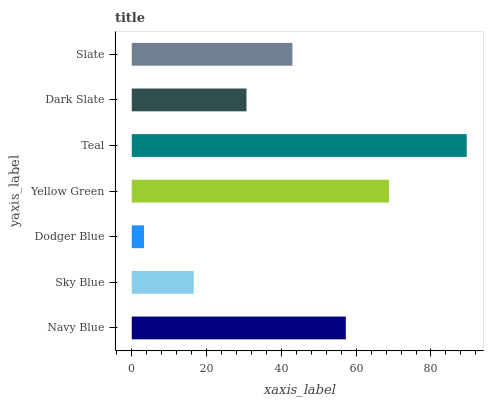Is Dodger Blue the minimum?
Answer yes or no. Yes. Is Teal the maximum?
Answer yes or no. Yes. Is Sky Blue the minimum?
Answer yes or no. No. Is Sky Blue the maximum?
Answer yes or no. No. Is Navy Blue greater than Sky Blue?
Answer yes or no. Yes. Is Sky Blue less than Navy Blue?
Answer yes or no. Yes. Is Sky Blue greater than Navy Blue?
Answer yes or no. No. Is Navy Blue less than Sky Blue?
Answer yes or no. No. Is Slate the high median?
Answer yes or no. Yes. Is Slate the low median?
Answer yes or no. Yes. Is Dodger Blue the high median?
Answer yes or no. No. Is Dark Slate the low median?
Answer yes or no. No. 